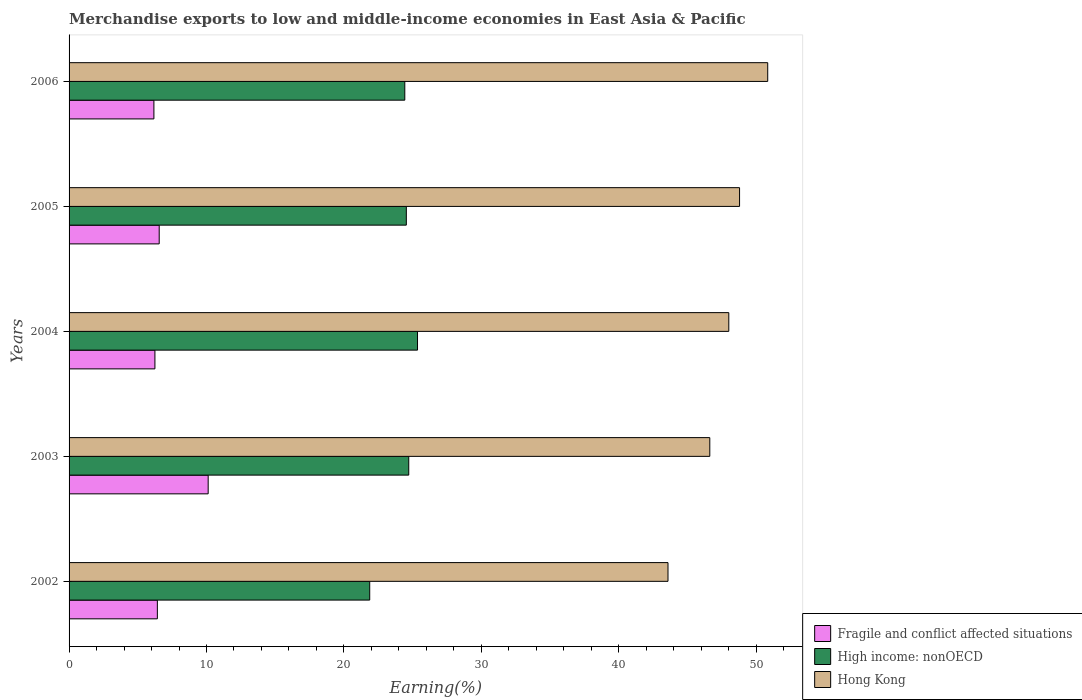How many groups of bars are there?
Provide a succinct answer. 5. Are the number of bars per tick equal to the number of legend labels?
Provide a succinct answer. Yes. How many bars are there on the 2nd tick from the top?
Ensure brevity in your answer.  3. What is the percentage of amount earned from merchandise exports in High income: nonOECD in 2003?
Offer a terse response. 24.72. Across all years, what is the maximum percentage of amount earned from merchandise exports in Fragile and conflict affected situations?
Make the answer very short. 10.12. Across all years, what is the minimum percentage of amount earned from merchandise exports in Hong Kong?
Give a very brief answer. 43.59. In which year was the percentage of amount earned from merchandise exports in Hong Kong maximum?
Provide a short and direct response. 2006. In which year was the percentage of amount earned from merchandise exports in High income: nonOECD minimum?
Ensure brevity in your answer.  2002. What is the total percentage of amount earned from merchandise exports in High income: nonOECD in the graph?
Keep it short and to the point. 120.93. What is the difference between the percentage of amount earned from merchandise exports in Fragile and conflict affected situations in 2003 and that in 2005?
Provide a short and direct response. 3.56. What is the difference between the percentage of amount earned from merchandise exports in High income: nonOECD in 2006 and the percentage of amount earned from merchandise exports in Hong Kong in 2002?
Ensure brevity in your answer.  -19.15. What is the average percentage of amount earned from merchandise exports in Hong Kong per year?
Provide a succinct answer. 47.57. In the year 2002, what is the difference between the percentage of amount earned from merchandise exports in Hong Kong and percentage of amount earned from merchandise exports in Fragile and conflict affected situations?
Offer a terse response. 37.16. In how many years, is the percentage of amount earned from merchandise exports in High income: nonOECD greater than 34 %?
Ensure brevity in your answer.  0. What is the ratio of the percentage of amount earned from merchandise exports in Fragile and conflict affected situations in 2003 to that in 2006?
Offer a very short reply. 1.64. Is the difference between the percentage of amount earned from merchandise exports in Hong Kong in 2003 and 2006 greater than the difference between the percentage of amount earned from merchandise exports in Fragile and conflict affected situations in 2003 and 2006?
Make the answer very short. No. What is the difference between the highest and the second highest percentage of amount earned from merchandise exports in High income: nonOECD?
Keep it short and to the point. 0.64. What is the difference between the highest and the lowest percentage of amount earned from merchandise exports in Hong Kong?
Your answer should be very brief. 7.26. In how many years, is the percentage of amount earned from merchandise exports in Fragile and conflict affected situations greater than the average percentage of amount earned from merchandise exports in Fragile and conflict affected situations taken over all years?
Your response must be concise. 1. Is the sum of the percentage of amount earned from merchandise exports in Fragile and conflict affected situations in 2002 and 2004 greater than the maximum percentage of amount earned from merchandise exports in Hong Kong across all years?
Offer a very short reply. No. What does the 1st bar from the top in 2005 represents?
Your response must be concise. Hong Kong. What does the 3rd bar from the bottom in 2002 represents?
Keep it short and to the point. Hong Kong. How many bars are there?
Offer a terse response. 15. How many years are there in the graph?
Your response must be concise. 5. Where does the legend appear in the graph?
Give a very brief answer. Bottom right. How are the legend labels stacked?
Your response must be concise. Vertical. What is the title of the graph?
Give a very brief answer. Merchandise exports to low and middle-income economies in East Asia & Pacific. Does "Iraq" appear as one of the legend labels in the graph?
Keep it short and to the point. No. What is the label or title of the X-axis?
Offer a terse response. Earning(%). What is the label or title of the Y-axis?
Your answer should be very brief. Years. What is the Earning(%) of Fragile and conflict affected situations in 2002?
Keep it short and to the point. 6.42. What is the Earning(%) in High income: nonOECD in 2002?
Your answer should be very brief. 21.88. What is the Earning(%) of Hong Kong in 2002?
Give a very brief answer. 43.59. What is the Earning(%) in Fragile and conflict affected situations in 2003?
Give a very brief answer. 10.12. What is the Earning(%) in High income: nonOECD in 2003?
Offer a very short reply. 24.72. What is the Earning(%) of Hong Kong in 2003?
Ensure brevity in your answer.  46.63. What is the Earning(%) of Fragile and conflict affected situations in 2004?
Make the answer very short. 6.25. What is the Earning(%) in High income: nonOECD in 2004?
Your answer should be compact. 25.36. What is the Earning(%) of Hong Kong in 2004?
Your answer should be very brief. 48.01. What is the Earning(%) of Fragile and conflict affected situations in 2005?
Ensure brevity in your answer.  6.56. What is the Earning(%) of High income: nonOECD in 2005?
Offer a terse response. 24.54. What is the Earning(%) of Hong Kong in 2005?
Give a very brief answer. 48.79. What is the Earning(%) in Fragile and conflict affected situations in 2006?
Give a very brief answer. 6.17. What is the Earning(%) of High income: nonOECD in 2006?
Ensure brevity in your answer.  24.43. What is the Earning(%) in Hong Kong in 2006?
Provide a short and direct response. 50.84. Across all years, what is the maximum Earning(%) in Fragile and conflict affected situations?
Your answer should be very brief. 10.12. Across all years, what is the maximum Earning(%) of High income: nonOECD?
Make the answer very short. 25.36. Across all years, what is the maximum Earning(%) of Hong Kong?
Offer a terse response. 50.84. Across all years, what is the minimum Earning(%) in Fragile and conflict affected situations?
Offer a very short reply. 6.17. Across all years, what is the minimum Earning(%) of High income: nonOECD?
Keep it short and to the point. 21.88. Across all years, what is the minimum Earning(%) of Hong Kong?
Your answer should be very brief. 43.59. What is the total Earning(%) of Fragile and conflict affected situations in the graph?
Ensure brevity in your answer.  35.53. What is the total Earning(%) in High income: nonOECD in the graph?
Keep it short and to the point. 120.93. What is the total Earning(%) in Hong Kong in the graph?
Your response must be concise. 237.86. What is the difference between the Earning(%) of Fragile and conflict affected situations in 2002 and that in 2003?
Offer a terse response. -3.7. What is the difference between the Earning(%) of High income: nonOECD in 2002 and that in 2003?
Offer a very short reply. -2.84. What is the difference between the Earning(%) of Hong Kong in 2002 and that in 2003?
Make the answer very short. -3.04. What is the difference between the Earning(%) in Fragile and conflict affected situations in 2002 and that in 2004?
Provide a short and direct response. 0.18. What is the difference between the Earning(%) of High income: nonOECD in 2002 and that in 2004?
Offer a very short reply. -3.48. What is the difference between the Earning(%) of Hong Kong in 2002 and that in 2004?
Offer a very short reply. -4.42. What is the difference between the Earning(%) of Fragile and conflict affected situations in 2002 and that in 2005?
Ensure brevity in your answer.  -0.14. What is the difference between the Earning(%) of High income: nonOECD in 2002 and that in 2005?
Make the answer very short. -2.66. What is the difference between the Earning(%) of Hong Kong in 2002 and that in 2005?
Your answer should be very brief. -5.21. What is the difference between the Earning(%) in Fragile and conflict affected situations in 2002 and that in 2006?
Keep it short and to the point. 0.25. What is the difference between the Earning(%) in High income: nonOECD in 2002 and that in 2006?
Offer a terse response. -2.55. What is the difference between the Earning(%) of Hong Kong in 2002 and that in 2006?
Your response must be concise. -7.26. What is the difference between the Earning(%) in Fragile and conflict affected situations in 2003 and that in 2004?
Provide a short and direct response. 3.88. What is the difference between the Earning(%) in High income: nonOECD in 2003 and that in 2004?
Keep it short and to the point. -0.64. What is the difference between the Earning(%) in Hong Kong in 2003 and that in 2004?
Your response must be concise. -1.38. What is the difference between the Earning(%) of Fragile and conflict affected situations in 2003 and that in 2005?
Ensure brevity in your answer.  3.56. What is the difference between the Earning(%) of High income: nonOECD in 2003 and that in 2005?
Your answer should be very brief. 0.18. What is the difference between the Earning(%) in Hong Kong in 2003 and that in 2005?
Offer a terse response. -2.17. What is the difference between the Earning(%) of Fragile and conflict affected situations in 2003 and that in 2006?
Offer a very short reply. 3.95. What is the difference between the Earning(%) in High income: nonOECD in 2003 and that in 2006?
Your response must be concise. 0.29. What is the difference between the Earning(%) in Hong Kong in 2003 and that in 2006?
Provide a short and direct response. -4.22. What is the difference between the Earning(%) in Fragile and conflict affected situations in 2004 and that in 2005?
Your answer should be very brief. -0.31. What is the difference between the Earning(%) in High income: nonOECD in 2004 and that in 2005?
Ensure brevity in your answer.  0.81. What is the difference between the Earning(%) of Hong Kong in 2004 and that in 2005?
Provide a succinct answer. -0.78. What is the difference between the Earning(%) in Fragile and conflict affected situations in 2004 and that in 2006?
Your answer should be very brief. 0.07. What is the difference between the Earning(%) in High income: nonOECD in 2004 and that in 2006?
Give a very brief answer. 0.93. What is the difference between the Earning(%) in Hong Kong in 2004 and that in 2006?
Your response must be concise. -2.83. What is the difference between the Earning(%) in Fragile and conflict affected situations in 2005 and that in 2006?
Provide a succinct answer. 0.39. What is the difference between the Earning(%) in High income: nonOECD in 2005 and that in 2006?
Provide a succinct answer. 0.11. What is the difference between the Earning(%) of Hong Kong in 2005 and that in 2006?
Provide a short and direct response. -2.05. What is the difference between the Earning(%) in Fragile and conflict affected situations in 2002 and the Earning(%) in High income: nonOECD in 2003?
Offer a terse response. -18.3. What is the difference between the Earning(%) of Fragile and conflict affected situations in 2002 and the Earning(%) of Hong Kong in 2003?
Provide a succinct answer. -40.2. What is the difference between the Earning(%) in High income: nonOECD in 2002 and the Earning(%) in Hong Kong in 2003?
Offer a terse response. -24.75. What is the difference between the Earning(%) in Fragile and conflict affected situations in 2002 and the Earning(%) in High income: nonOECD in 2004?
Make the answer very short. -18.93. What is the difference between the Earning(%) of Fragile and conflict affected situations in 2002 and the Earning(%) of Hong Kong in 2004?
Offer a terse response. -41.59. What is the difference between the Earning(%) in High income: nonOECD in 2002 and the Earning(%) in Hong Kong in 2004?
Keep it short and to the point. -26.13. What is the difference between the Earning(%) in Fragile and conflict affected situations in 2002 and the Earning(%) in High income: nonOECD in 2005?
Offer a terse response. -18.12. What is the difference between the Earning(%) in Fragile and conflict affected situations in 2002 and the Earning(%) in Hong Kong in 2005?
Your answer should be compact. -42.37. What is the difference between the Earning(%) of High income: nonOECD in 2002 and the Earning(%) of Hong Kong in 2005?
Provide a succinct answer. -26.91. What is the difference between the Earning(%) in Fragile and conflict affected situations in 2002 and the Earning(%) in High income: nonOECD in 2006?
Your answer should be very brief. -18.01. What is the difference between the Earning(%) of Fragile and conflict affected situations in 2002 and the Earning(%) of Hong Kong in 2006?
Provide a succinct answer. -44.42. What is the difference between the Earning(%) of High income: nonOECD in 2002 and the Earning(%) of Hong Kong in 2006?
Offer a very short reply. -28.96. What is the difference between the Earning(%) in Fragile and conflict affected situations in 2003 and the Earning(%) in High income: nonOECD in 2004?
Your answer should be compact. -15.23. What is the difference between the Earning(%) in Fragile and conflict affected situations in 2003 and the Earning(%) in Hong Kong in 2004?
Your response must be concise. -37.89. What is the difference between the Earning(%) in High income: nonOECD in 2003 and the Earning(%) in Hong Kong in 2004?
Ensure brevity in your answer.  -23.29. What is the difference between the Earning(%) of Fragile and conflict affected situations in 2003 and the Earning(%) of High income: nonOECD in 2005?
Offer a very short reply. -14.42. What is the difference between the Earning(%) of Fragile and conflict affected situations in 2003 and the Earning(%) of Hong Kong in 2005?
Your response must be concise. -38.67. What is the difference between the Earning(%) of High income: nonOECD in 2003 and the Earning(%) of Hong Kong in 2005?
Provide a short and direct response. -24.07. What is the difference between the Earning(%) in Fragile and conflict affected situations in 2003 and the Earning(%) in High income: nonOECD in 2006?
Give a very brief answer. -14.31. What is the difference between the Earning(%) in Fragile and conflict affected situations in 2003 and the Earning(%) in Hong Kong in 2006?
Offer a very short reply. -40.72. What is the difference between the Earning(%) in High income: nonOECD in 2003 and the Earning(%) in Hong Kong in 2006?
Keep it short and to the point. -26.12. What is the difference between the Earning(%) of Fragile and conflict affected situations in 2004 and the Earning(%) of High income: nonOECD in 2005?
Give a very brief answer. -18.3. What is the difference between the Earning(%) of Fragile and conflict affected situations in 2004 and the Earning(%) of Hong Kong in 2005?
Provide a short and direct response. -42.55. What is the difference between the Earning(%) in High income: nonOECD in 2004 and the Earning(%) in Hong Kong in 2005?
Provide a short and direct response. -23.44. What is the difference between the Earning(%) in Fragile and conflict affected situations in 2004 and the Earning(%) in High income: nonOECD in 2006?
Offer a terse response. -18.18. What is the difference between the Earning(%) of Fragile and conflict affected situations in 2004 and the Earning(%) of Hong Kong in 2006?
Make the answer very short. -44.6. What is the difference between the Earning(%) in High income: nonOECD in 2004 and the Earning(%) in Hong Kong in 2006?
Your answer should be compact. -25.48. What is the difference between the Earning(%) of Fragile and conflict affected situations in 2005 and the Earning(%) of High income: nonOECD in 2006?
Provide a short and direct response. -17.87. What is the difference between the Earning(%) in Fragile and conflict affected situations in 2005 and the Earning(%) in Hong Kong in 2006?
Ensure brevity in your answer.  -44.28. What is the difference between the Earning(%) of High income: nonOECD in 2005 and the Earning(%) of Hong Kong in 2006?
Provide a succinct answer. -26.3. What is the average Earning(%) in Fragile and conflict affected situations per year?
Your answer should be very brief. 7.11. What is the average Earning(%) in High income: nonOECD per year?
Keep it short and to the point. 24.19. What is the average Earning(%) of Hong Kong per year?
Offer a terse response. 47.57. In the year 2002, what is the difference between the Earning(%) of Fragile and conflict affected situations and Earning(%) of High income: nonOECD?
Give a very brief answer. -15.45. In the year 2002, what is the difference between the Earning(%) in Fragile and conflict affected situations and Earning(%) in Hong Kong?
Ensure brevity in your answer.  -37.16. In the year 2002, what is the difference between the Earning(%) in High income: nonOECD and Earning(%) in Hong Kong?
Make the answer very short. -21.71. In the year 2003, what is the difference between the Earning(%) of Fragile and conflict affected situations and Earning(%) of High income: nonOECD?
Offer a terse response. -14.6. In the year 2003, what is the difference between the Earning(%) in Fragile and conflict affected situations and Earning(%) in Hong Kong?
Provide a succinct answer. -36.5. In the year 2003, what is the difference between the Earning(%) of High income: nonOECD and Earning(%) of Hong Kong?
Give a very brief answer. -21.91. In the year 2004, what is the difference between the Earning(%) in Fragile and conflict affected situations and Earning(%) in High income: nonOECD?
Your response must be concise. -19.11. In the year 2004, what is the difference between the Earning(%) of Fragile and conflict affected situations and Earning(%) of Hong Kong?
Give a very brief answer. -41.76. In the year 2004, what is the difference between the Earning(%) of High income: nonOECD and Earning(%) of Hong Kong?
Offer a terse response. -22.65. In the year 2005, what is the difference between the Earning(%) of Fragile and conflict affected situations and Earning(%) of High income: nonOECD?
Your answer should be very brief. -17.98. In the year 2005, what is the difference between the Earning(%) of Fragile and conflict affected situations and Earning(%) of Hong Kong?
Your answer should be very brief. -42.23. In the year 2005, what is the difference between the Earning(%) of High income: nonOECD and Earning(%) of Hong Kong?
Give a very brief answer. -24.25. In the year 2006, what is the difference between the Earning(%) of Fragile and conflict affected situations and Earning(%) of High income: nonOECD?
Ensure brevity in your answer.  -18.26. In the year 2006, what is the difference between the Earning(%) in Fragile and conflict affected situations and Earning(%) in Hong Kong?
Provide a short and direct response. -44.67. In the year 2006, what is the difference between the Earning(%) in High income: nonOECD and Earning(%) in Hong Kong?
Make the answer very short. -26.41. What is the ratio of the Earning(%) of Fragile and conflict affected situations in 2002 to that in 2003?
Keep it short and to the point. 0.63. What is the ratio of the Earning(%) of High income: nonOECD in 2002 to that in 2003?
Offer a terse response. 0.89. What is the ratio of the Earning(%) in Hong Kong in 2002 to that in 2003?
Make the answer very short. 0.93. What is the ratio of the Earning(%) of Fragile and conflict affected situations in 2002 to that in 2004?
Give a very brief answer. 1.03. What is the ratio of the Earning(%) in High income: nonOECD in 2002 to that in 2004?
Provide a short and direct response. 0.86. What is the ratio of the Earning(%) of Hong Kong in 2002 to that in 2004?
Your answer should be compact. 0.91. What is the ratio of the Earning(%) in Fragile and conflict affected situations in 2002 to that in 2005?
Keep it short and to the point. 0.98. What is the ratio of the Earning(%) of High income: nonOECD in 2002 to that in 2005?
Offer a very short reply. 0.89. What is the ratio of the Earning(%) of Hong Kong in 2002 to that in 2005?
Provide a succinct answer. 0.89. What is the ratio of the Earning(%) in Fragile and conflict affected situations in 2002 to that in 2006?
Your answer should be very brief. 1.04. What is the ratio of the Earning(%) in High income: nonOECD in 2002 to that in 2006?
Keep it short and to the point. 0.9. What is the ratio of the Earning(%) of Hong Kong in 2002 to that in 2006?
Offer a terse response. 0.86. What is the ratio of the Earning(%) in Fragile and conflict affected situations in 2003 to that in 2004?
Ensure brevity in your answer.  1.62. What is the ratio of the Earning(%) of High income: nonOECD in 2003 to that in 2004?
Your response must be concise. 0.97. What is the ratio of the Earning(%) of Hong Kong in 2003 to that in 2004?
Your response must be concise. 0.97. What is the ratio of the Earning(%) in Fragile and conflict affected situations in 2003 to that in 2005?
Provide a short and direct response. 1.54. What is the ratio of the Earning(%) of Hong Kong in 2003 to that in 2005?
Provide a short and direct response. 0.96. What is the ratio of the Earning(%) of Fragile and conflict affected situations in 2003 to that in 2006?
Ensure brevity in your answer.  1.64. What is the ratio of the Earning(%) in High income: nonOECD in 2003 to that in 2006?
Make the answer very short. 1.01. What is the ratio of the Earning(%) of Hong Kong in 2003 to that in 2006?
Offer a very short reply. 0.92. What is the ratio of the Earning(%) of High income: nonOECD in 2004 to that in 2005?
Your answer should be compact. 1.03. What is the ratio of the Earning(%) in Fragile and conflict affected situations in 2004 to that in 2006?
Your answer should be compact. 1.01. What is the ratio of the Earning(%) in High income: nonOECD in 2004 to that in 2006?
Offer a terse response. 1.04. What is the ratio of the Earning(%) of Hong Kong in 2004 to that in 2006?
Keep it short and to the point. 0.94. What is the ratio of the Earning(%) of Fragile and conflict affected situations in 2005 to that in 2006?
Your answer should be compact. 1.06. What is the ratio of the Earning(%) of High income: nonOECD in 2005 to that in 2006?
Your answer should be compact. 1. What is the ratio of the Earning(%) of Hong Kong in 2005 to that in 2006?
Provide a short and direct response. 0.96. What is the difference between the highest and the second highest Earning(%) in Fragile and conflict affected situations?
Ensure brevity in your answer.  3.56. What is the difference between the highest and the second highest Earning(%) in High income: nonOECD?
Provide a short and direct response. 0.64. What is the difference between the highest and the second highest Earning(%) in Hong Kong?
Your answer should be compact. 2.05. What is the difference between the highest and the lowest Earning(%) of Fragile and conflict affected situations?
Your answer should be very brief. 3.95. What is the difference between the highest and the lowest Earning(%) of High income: nonOECD?
Offer a very short reply. 3.48. What is the difference between the highest and the lowest Earning(%) of Hong Kong?
Make the answer very short. 7.26. 